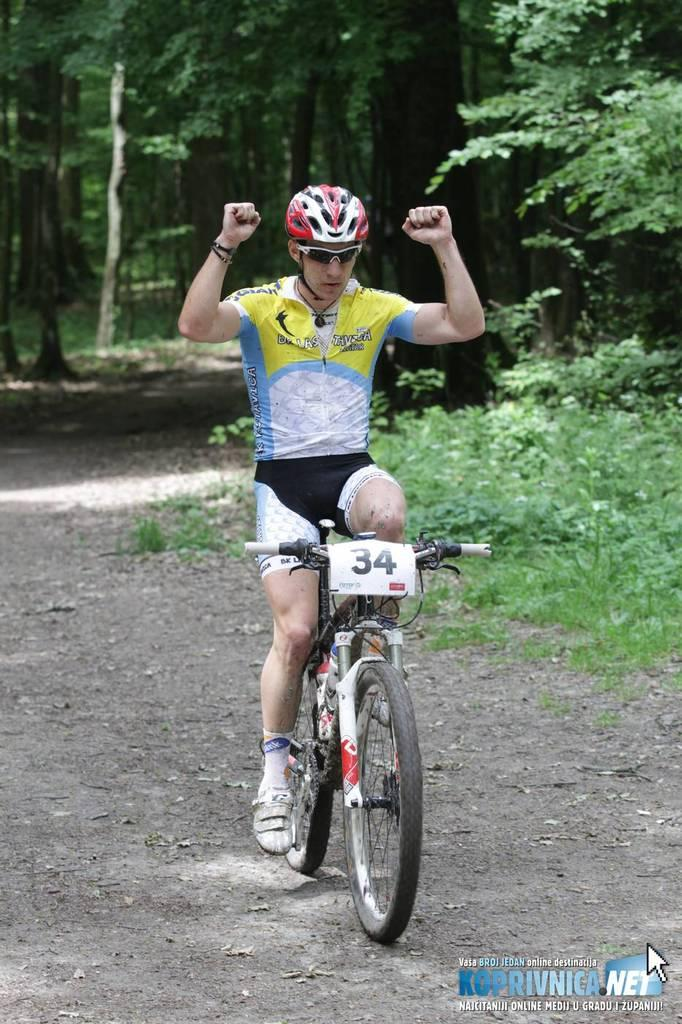What is the person in the image doing? The person is cycling on the road. What is the person wearing while cycling? The person is wearing a helmet. What type of vehicle is the person using? The person is sitting on a bicycle. What can be seen in the background of the image? There are trees, plants, and grass in the background of the image. What color is the paint on the bicycle in the image? There is no mention of the bicycle's paint color in the provided facts, so it cannot be determined from the image. 